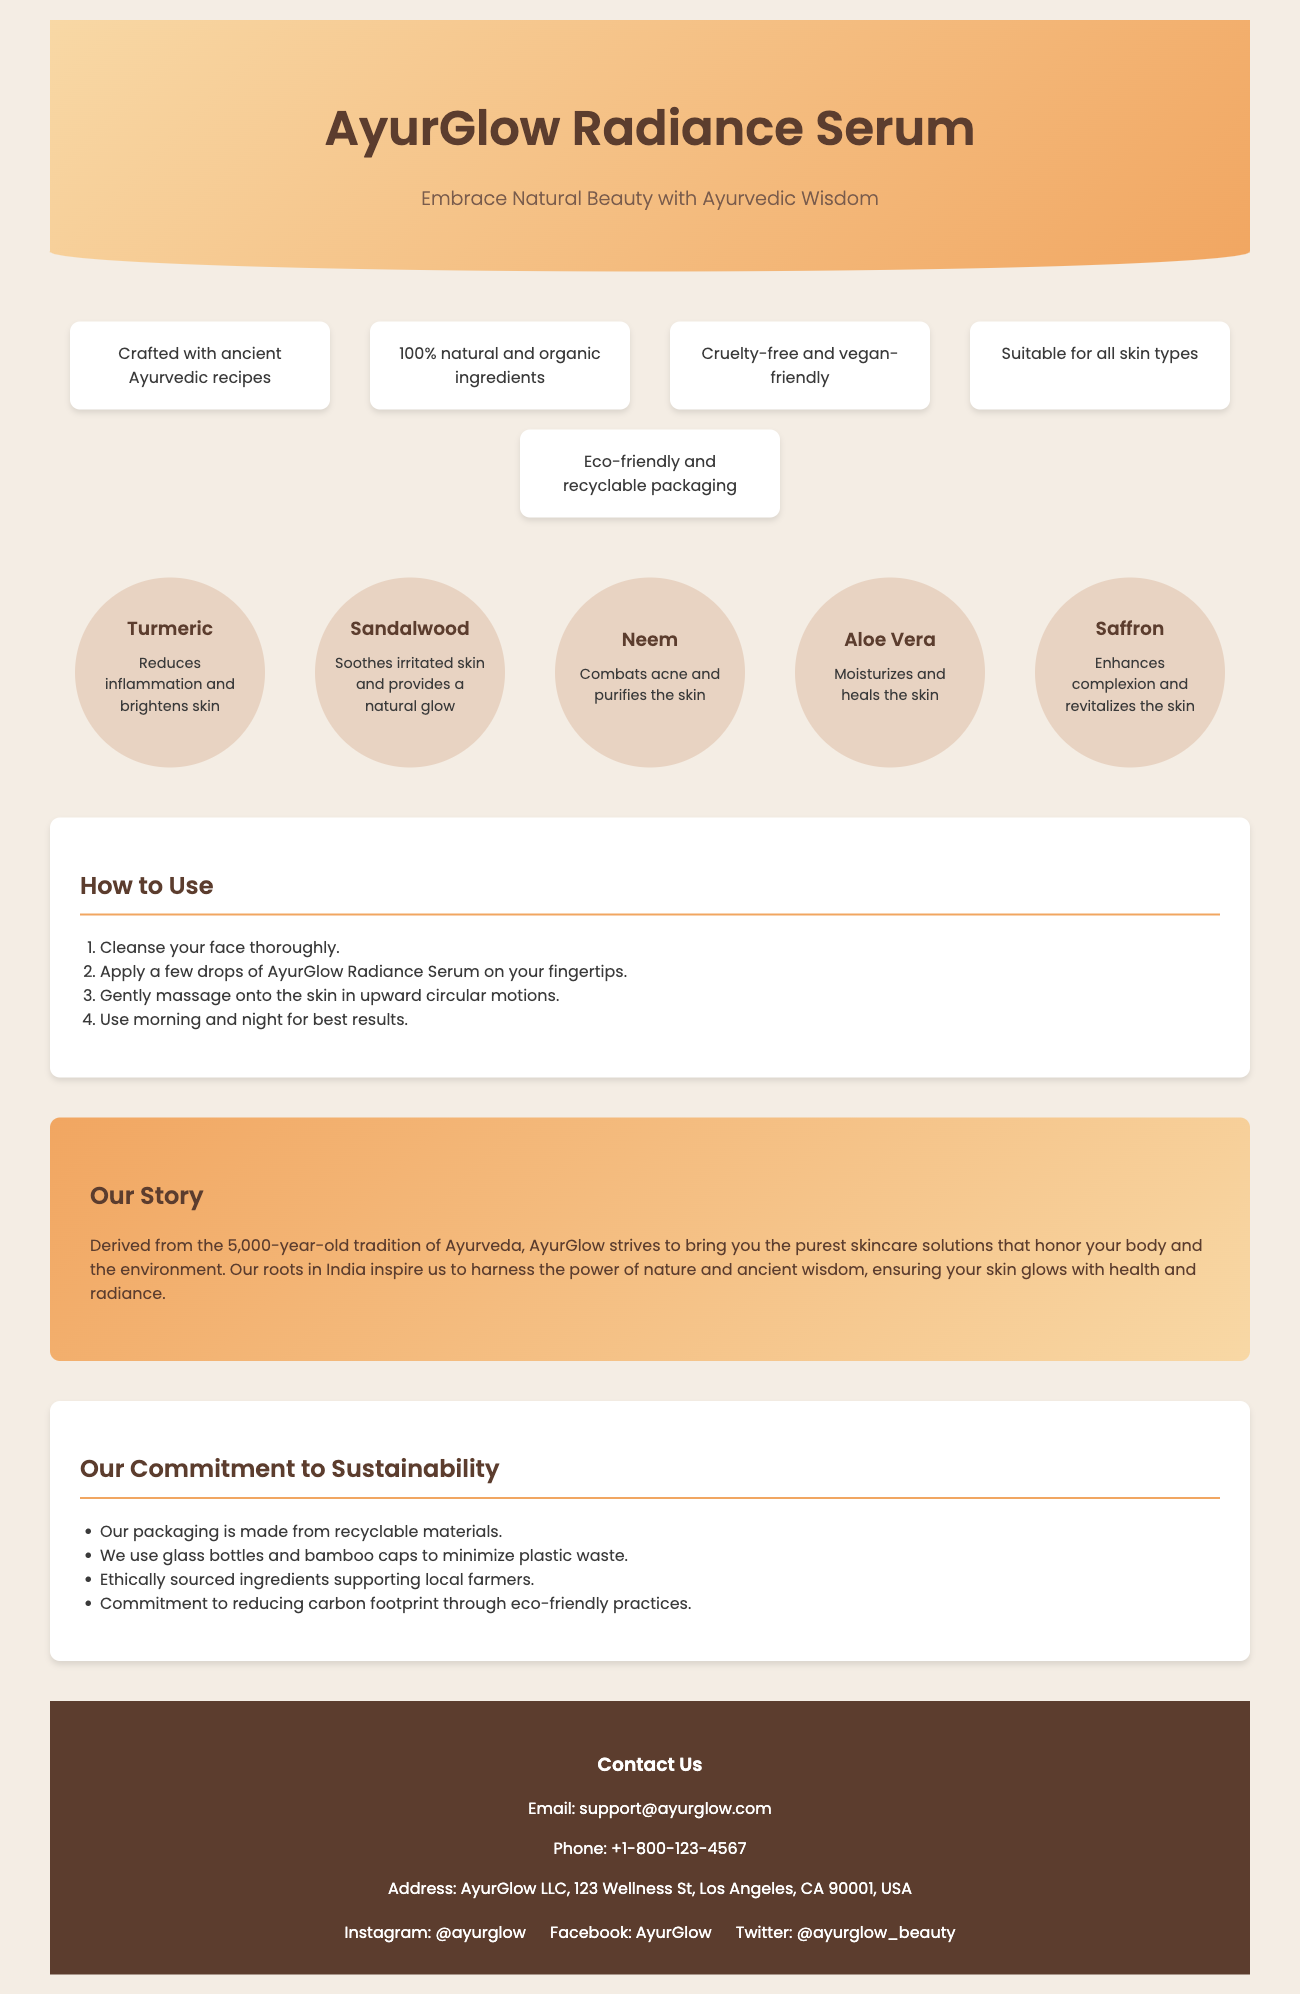What is the product name? The product name is prominently displayed in the header section of the document.
Answer: AyurGlow Radiance Serum What is the tagline of the product? The tagline is a phrase that emphasizes the product's intention and is located right below the product name.
Answer: Embrace Natural Beauty with Ayurvedic Wisdom What are the main benefits highlighted? The document lists five key benefits of the product under the features section.
Answer: Crafted with ancient Ayurvedic recipes, 100% natural and organic ingredients, Cruelty-free and vegan-friendly, Suitable for all skin types, Eco-friendly and recyclable packaging What ingredient is known for reducing inflammation? The ingredient section includes specific properties of each ingredient, highlighting turmeric's benefits.
Answer: Turmeric How often should you use the serum for best results? The instructions section specifies the recommended frequency for usage of the product.
Answer: Morning and night What is the commitment to sustainability mentioned? The document outlines various sustainability practices in a dedicated section.
Answer: Our packaging is made from recyclable materials Where is the company based? The footer contains the address of the company which indicates its location.
Answer: Los Angeles, CA, USA What social media platforms are mentioned? The footer includes links to the brand’s social media profiles.
Answer: Instagram, Facebook, Twitter What type of packaging is used for the product? The sustainability section emphasizes the type of materials used for packaging.
Answer: Glass bottles and bamboo caps 